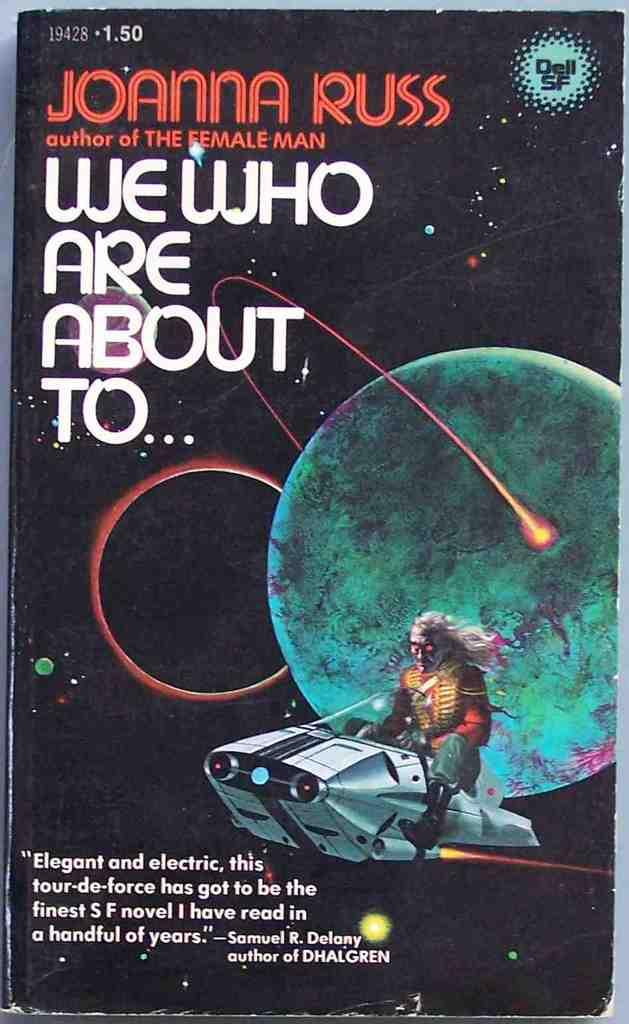Provide a one-sentence caption for the provided image. A book cover titled We Who Are About To by Joanna Russ and a picture of an alien on a space ship. 